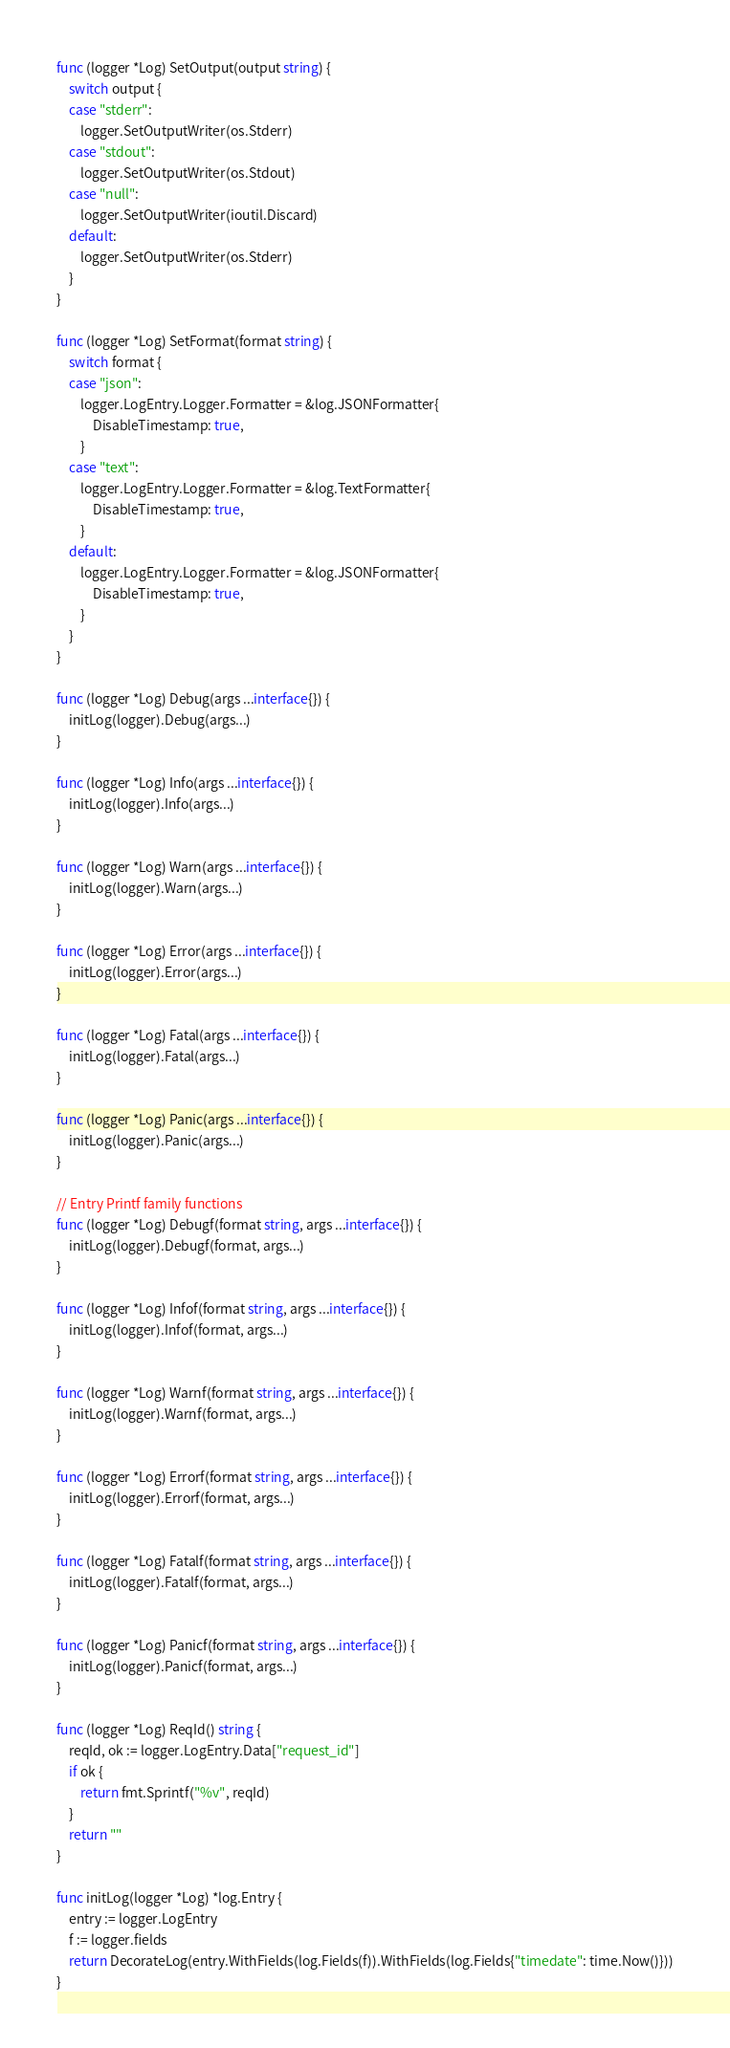<code> <loc_0><loc_0><loc_500><loc_500><_Go_>func (logger *Log) SetOutput(output string) {
	switch output {
	case "stderr":
		logger.SetOutputWriter(os.Stderr)
	case "stdout":
		logger.SetOutputWriter(os.Stdout)
	case "null":
		logger.SetOutputWriter(ioutil.Discard)
	default:
		logger.SetOutputWriter(os.Stderr)
	}
}

func (logger *Log) SetFormat(format string) {
	switch format {
	case "json":
		logger.LogEntry.Logger.Formatter = &log.JSONFormatter{
			DisableTimestamp: true,
		}
	case "text":
		logger.LogEntry.Logger.Formatter = &log.TextFormatter{
			DisableTimestamp: true,
		}
	default:
		logger.LogEntry.Logger.Formatter = &log.JSONFormatter{
			DisableTimestamp: true,
		}
	}
}

func (logger *Log) Debug(args ...interface{}) {
	initLog(logger).Debug(args...)
}

func (logger *Log) Info(args ...interface{}) {
	initLog(logger).Info(args...)
}

func (logger *Log) Warn(args ...interface{}) {
	initLog(logger).Warn(args...)
}

func (logger *Log) Error(args ...interface{}) {
	initLog(logger).Error(args...)
}

func (logger *Log) Fatal(args ...interface{}) {
	initLog(logger).Fatal(args...)
}

func (logger *Log) Panic(args ...interface{}) {
	initLog(logger).Panic(args...)
}

// Entry Printf family functions
func (logger *Log) Debugf(format string, args ...interface{}) {
	initLog(logger).Debugf(format, args...)
}

func (logger *Log) Infof(format string, args ...interface{}) {
	initLog(logger).Infof(format, args...)
}

func (logger *Log) Warnf(format string, args ...interface{}) {
	initLog(logger).Warnf(format, args...)
}

func (logger *Log) Errorf(format string, args ...interface{}) {
	initLog(logger).Errorf(format, args...)
}

func (logger *Log) Fatalf(format string, args ...interface{}) {
	initLog(logger).Fatalf(format, args...)
}

func (logger *Log) Panicf(format string, args ...interface{}) {
	initLog(logger).Panicf(format, args...)
}

func (logger *Log) ReqId() string {
	reqId, ok := logger.LogEntry.Data["request_id"]
	if ok {
		return fmt.Sprintf("%v", reqId)
	}
	return ""
}

func initLog(logger *Log) *log.Entry {
	entry := logger.LogEntry
	f := logger.fields
	return DecorateLog(entry.WithFields(log.Fields(f)).WithFields(log.Fields{"timedate": time.Now()}))
}
</code> 